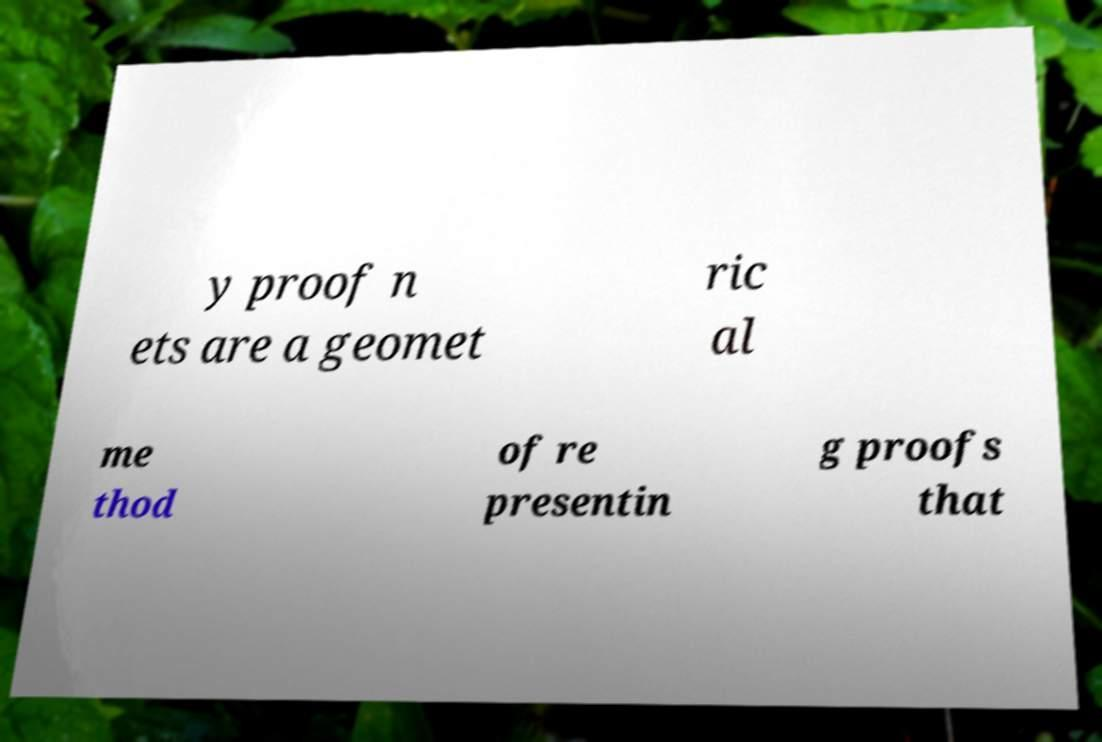Please read and relay the text visible in this image. What does it say? y proof n ets are a geomet ric al me thod of re presentin g proofs that 